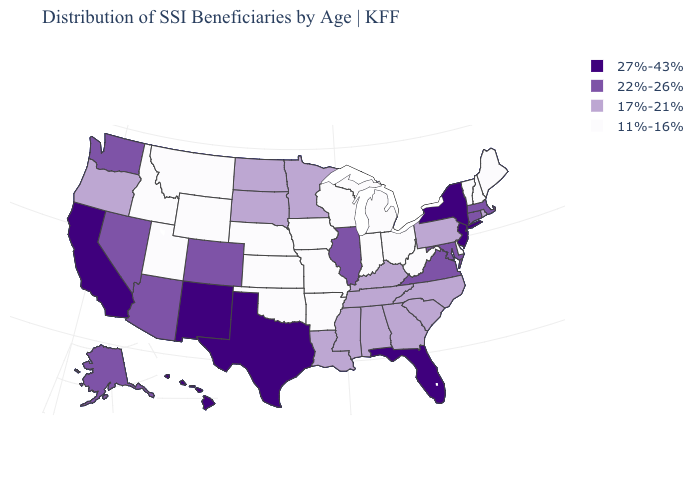What is the highest value in the USA?
Be succinct. 27%-43%. Does Oregon have a lower value than Louisiana?
Quick response, please. No. Does the first symbol in the legend represent the smallest category?
Quick response, please. No. Name the states that have a value in the range 17%-21%?
Quick response, please. Alabama, Georgia, Kentucky, Louisiana, Minnesota, Mississippi, North Carolina, North Dakota, Oregon, Pennsylvania, Rhode Island, South Carolina, South Dakota, Tennessee. Name the states that have a value in the range 27%-43%?
Short answer required. California, Florida, Hawaii, New Jersey, New Mexico, New York, Texas. Name the states that have a value in the range 27%-43%?
Concise answer only. California, Florida, Hawaii, New Jersey, New Mexico, New York, Texas. What is the value of New York?
Be succinct. 27%-43%. What is the value of Oregon?
Answer briefly. 17%-21%. What is the value of Indiana?
Quick response, please. 11%-16%. Does Georgia have the same value as Mississippi?
Short answer required. Yes. Does Alabama have the same value as Pennsylvania?
Be succinct. Yes. Name the states that have a value in the range 22%-26%?
Give a very brief answer. Alaska, Arizona, Colorado, Connecticut, Illinois, Maryland, Massachusetts, Nevada, Virginia, Washington. Does Massachusetts have the lowest value in the Northeast?
Keep it brief. No. What is the lowest value in the Northeast?
Keep it brief. 11%-16%. 